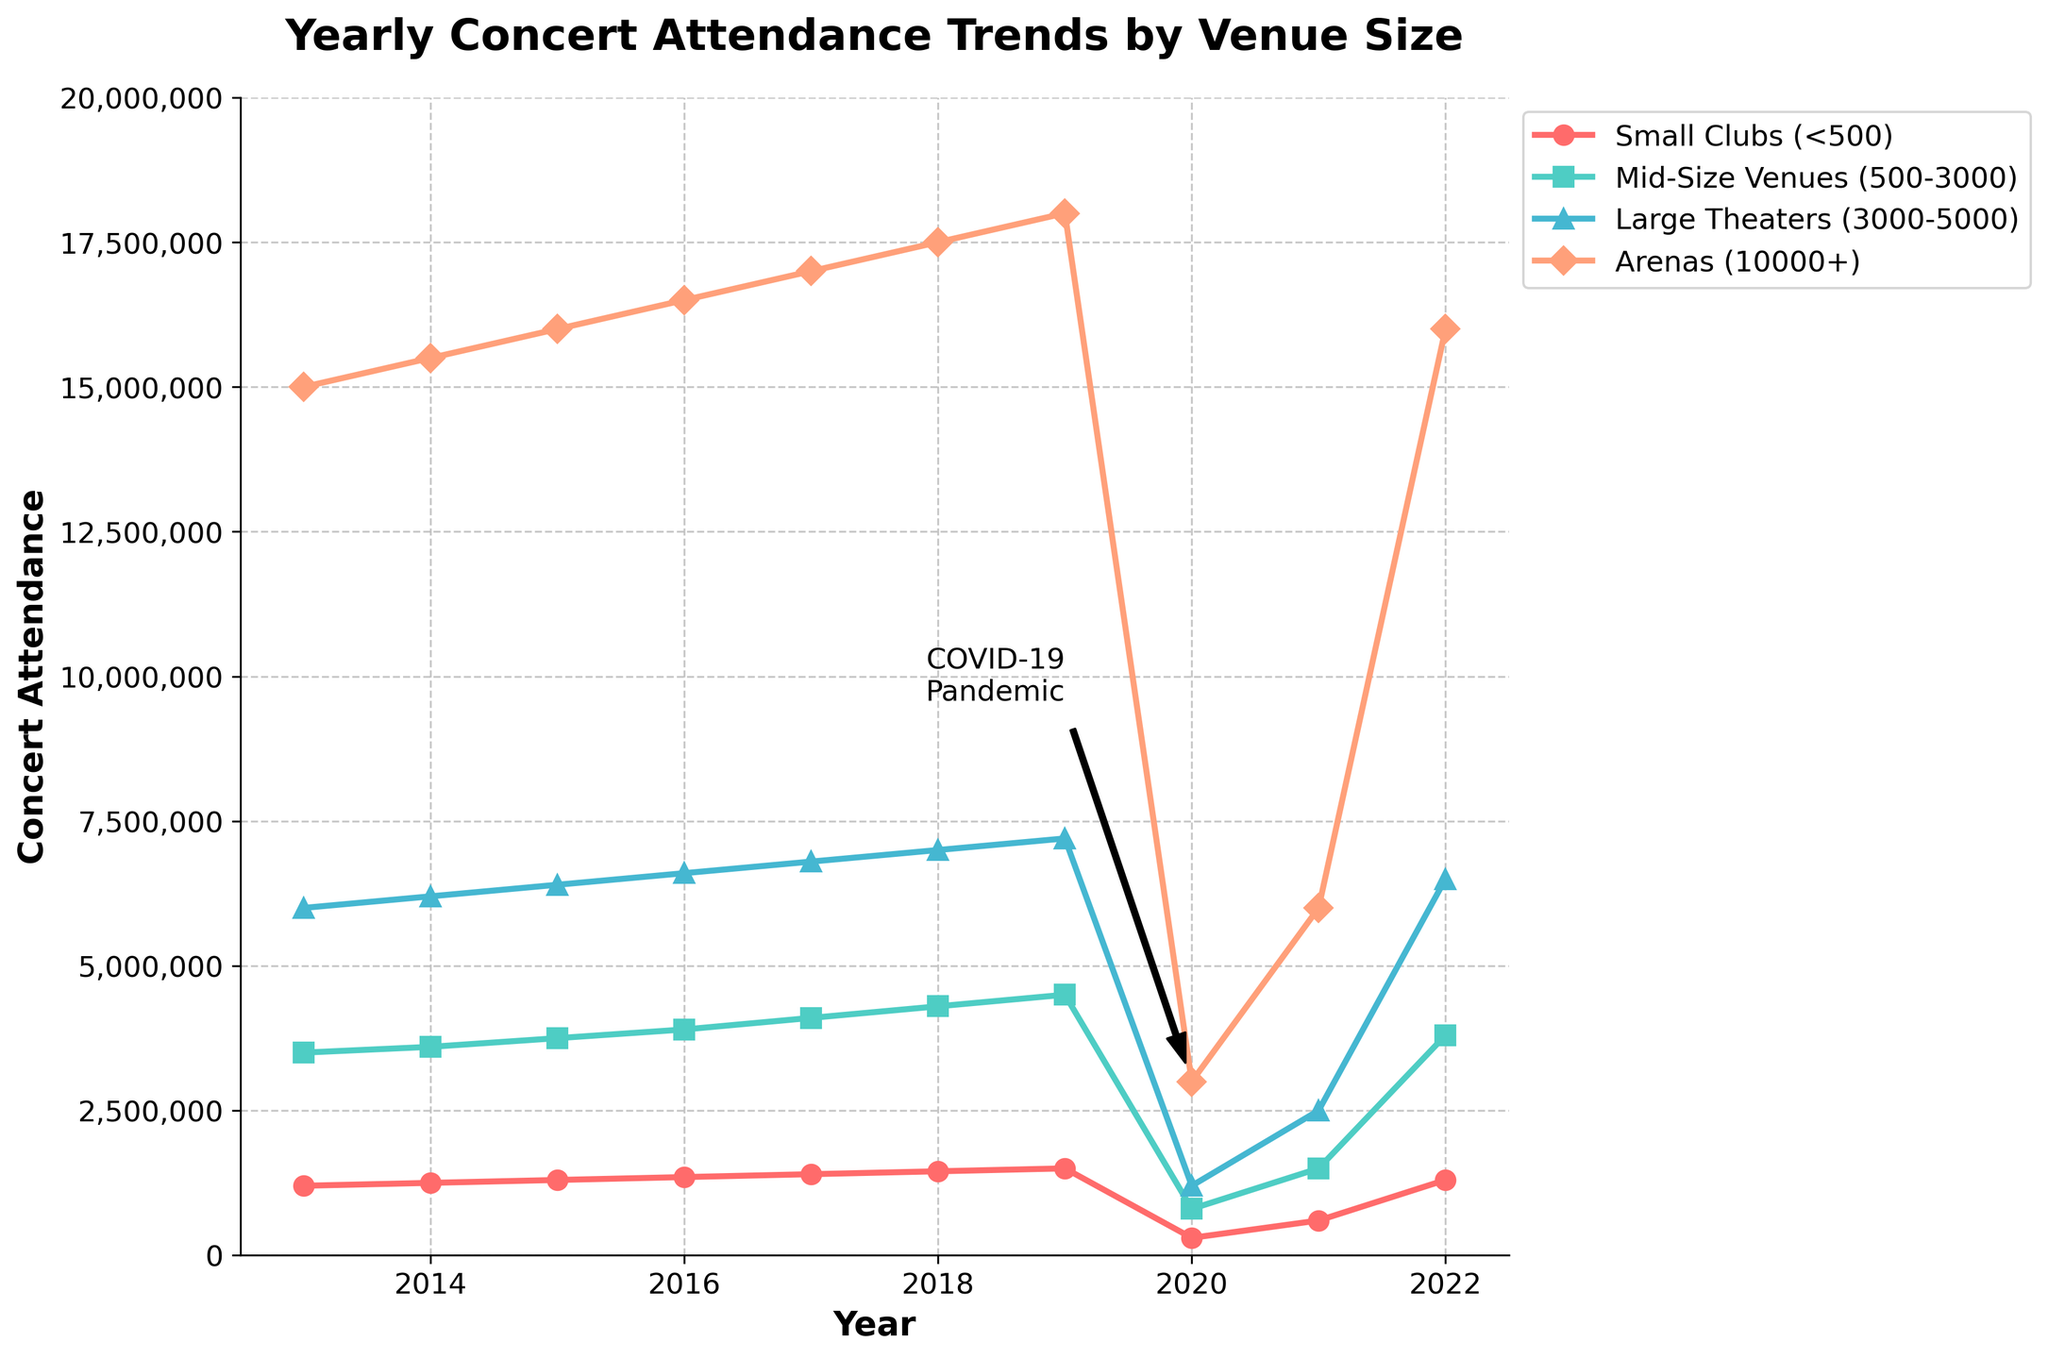What was the attendance at Small Clubs in 2020? Looking at the graph, locate the line for Small Clubs, which is marked with circles and colored red. On the x-axis, align with the year 2020, and read the corresponding y-axis value.
Answer: 300,000 Which year saw the highest concert attendance at Arenas? Find the line for Arenas marked with diamonds and colored light orange. Identify the year where this line reaches its highest point on the y-axis, which corresponds to a peak attendance value.
Answer: 2019 How did the attendance in Mid-Size Venues change from 2019 to 2020? Identify the line for Mid-Size Venues marked with squares and colored turquoise. Compare the y-axis values for the years 2019 and 2020. Subtract the 2020 value from the 2019 value to find the change.
Answer: Decreased by 3,700,000 What was the total concert attendance for Small Clubs and Mid-Size Venues in 2017? Locate the y-axis values for Small Clubs and Mid-Size Venues for the year 2017. Sum these two values to find the total attendance.
Answer: 5,500,000 Which venue size experienced the largest drop in attendance between 2019 and 2020? Compare the lines for all venue sizes between the years 2019 and 2020. Observe the largest vertical drop on the y-axis.
Answer: Arenas What trend is evident for all venue sizes from 2013 to 2019? Observe the movement of all four lines from 2013 to 2019. Note the general direction and pattern of the lines over these years.
Answer: Increasing What was the difference in attendance between Small Clubs and Arenas in 2022? For the year 2022, locate the y-axis values for Small Clubs and Arenas. Subtract the value for Small Clubs from the value for Arenas to find the difference.
Answer: 14,700,000 How did the attendance in Large Theaters recover from 2020 to 2021? Locate the y-axis values for Large Theaters for the years 2020 and 2021. Compare these values to see the change, noting the direction of the change.
Answer: Increased by 1,300,000 What visual annotation is provided on the figure, and what does it indicate? Identify any text or annotation directly on the figure; note its location and what period or data it refers to.
Answer: COVID-19 Pandemic, indicating significant impact around 2020 If 2019 was considered a peak year, by how much did the attendance in Mid-Size Venues decrease in 2020 as a percentage? Calculate the percentage decrease from the 2019 attendance to the 2020 attendance for Mid-Size Venues. Use the formula: ((value in 2019 - value in 2020) / value in 2019) * 100%.
Answer: Approximately 82.22% 